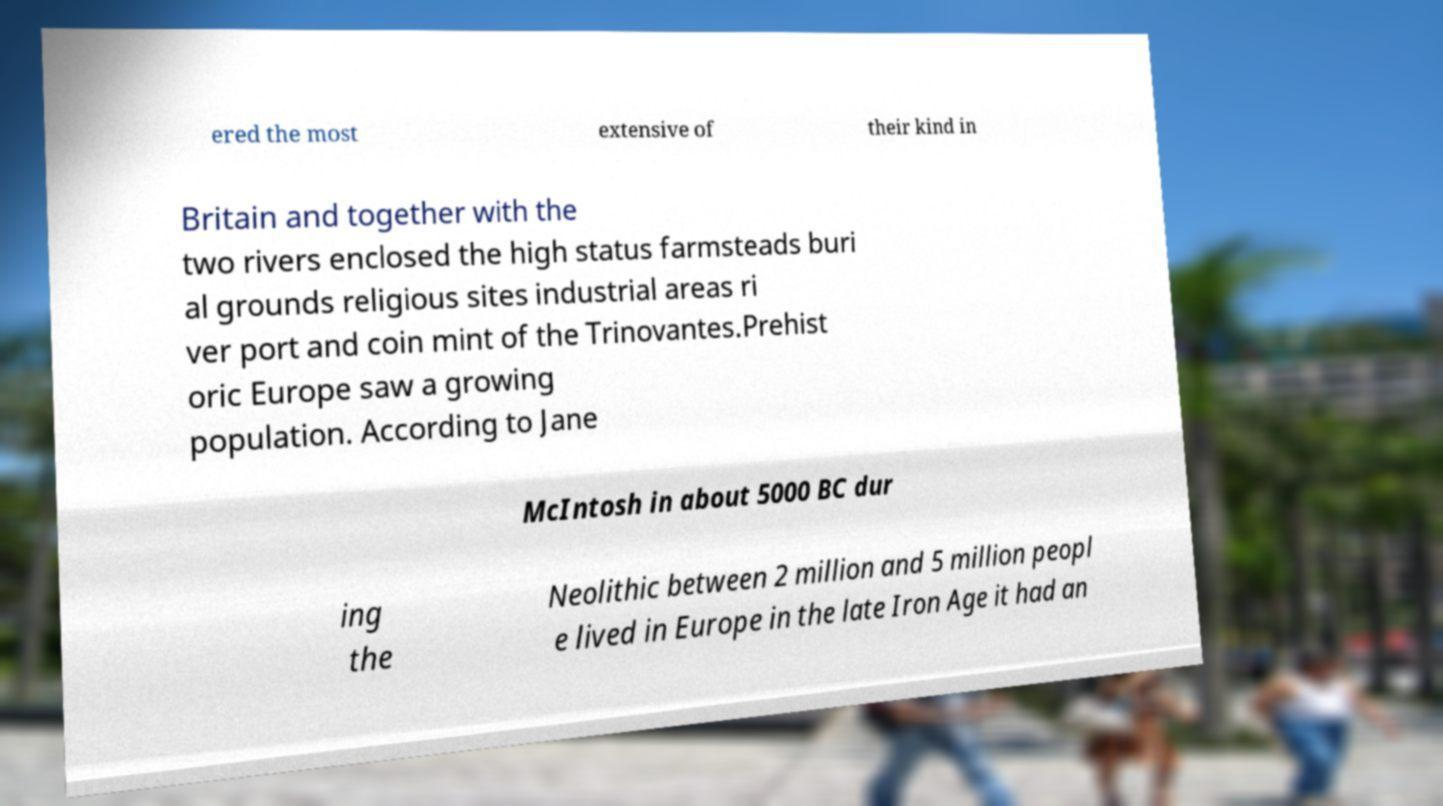Please identify and transcribe the text found in this image. ered the most extensive of their kind in Britain and together with the two rivers enclosed the high status farmsteads buri al grounds religious sites industrial areas ri ver port and coin mint of the Trinovantes.Prehist oric Europe saw a growing population. According to Jane McIntosh in about 5000 BC dur ing the Neolithic between 2 million and 5 million peopl e lived in Europe in the late Iron Age it had an 